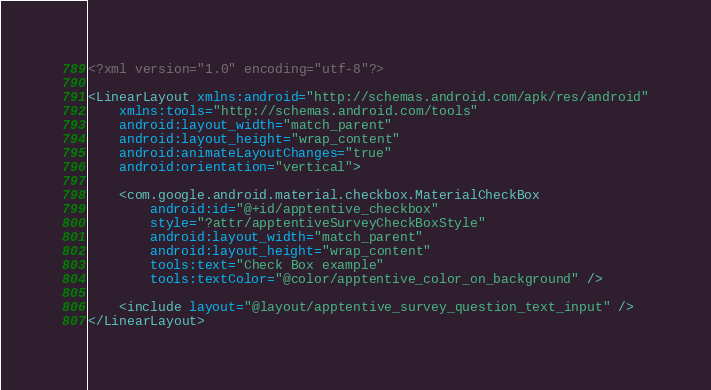<code> <loc_0><loc_0><loc_500><loc_500><_XML_><?xml version="1.0" encoding="utf-8"?>

<LinearLayout xmlns:android="http://schemas.android.com/apk/res/android"
    xmlns:tools="http://schemas.android.com/tools"
    android:layout_width="match_parent"
    android:layout_height="wrap_content"
    android:animateLayoutChanges="true"
    android:orientation="vertical">

    <com.google.android.material.checkbox.MaterialCheckBox
        android:id="@+id/apptentive_checkbox"
        style="?attr/apptentiveSurveyCheckBoxStyle"
        android:layout_width="match_parent"
        android:layout_height="wrap_content"
        tools:text="Check Box example"
        tools:textColor="@color/apptentive_color_on_background" />

    <include layout="@layout/apptentive_survey_question_text_input" />
</LinearLayout>
</code> 